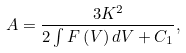<formula> <loc_0><loc_0><loc_500><loc_500>A = \frac { 3 K ^ { 2 } } { 2 \int F \left ( V \right ) d V + C _ { 1 } } ,</formula> 